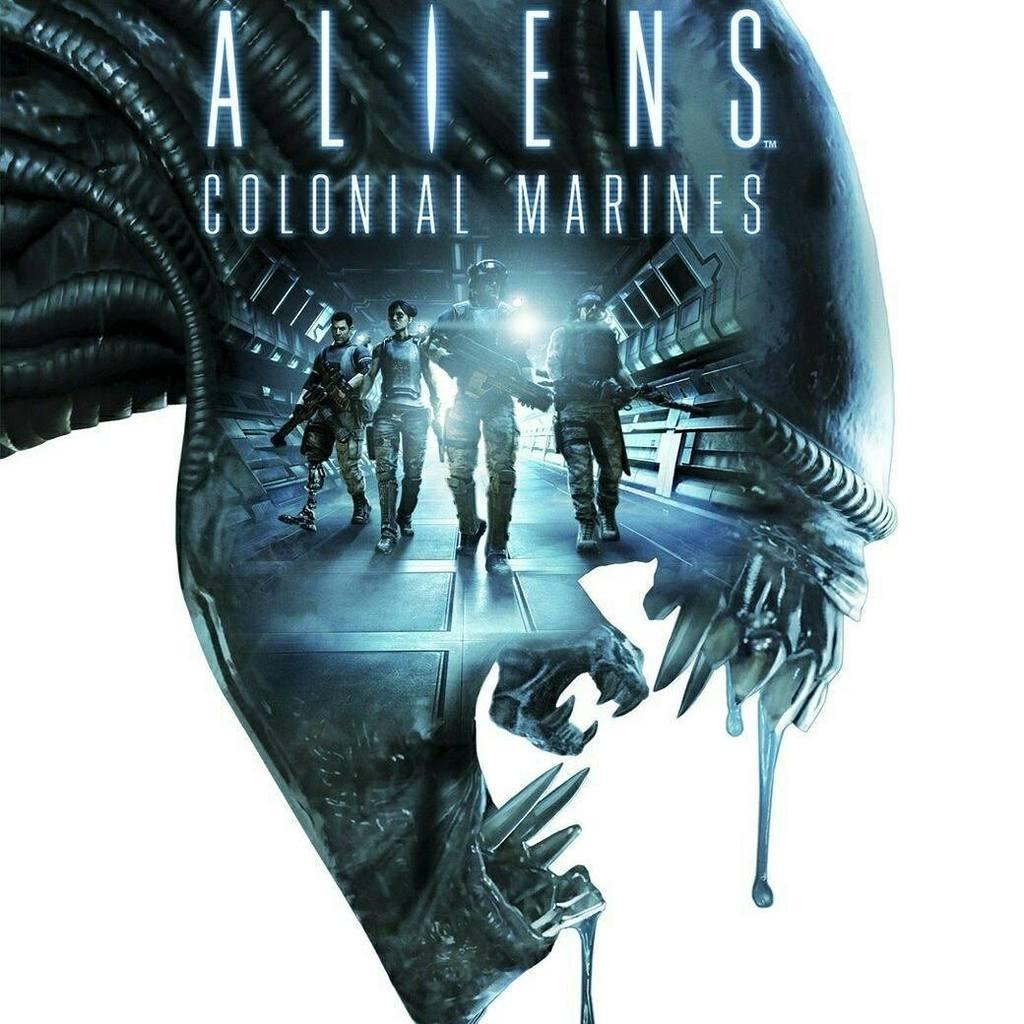What is the main subject of the picture? The main subject of the picture is a sculpture. What can be seen on the sculpture? The sculpture has some persons depicted on it. Is there any text present on the sculpture? Yes, there is text on the sculpture. What type of crate is used to store the sculpture in the image? There is no crate present in the image; the sculpture is visible as the main subject. 